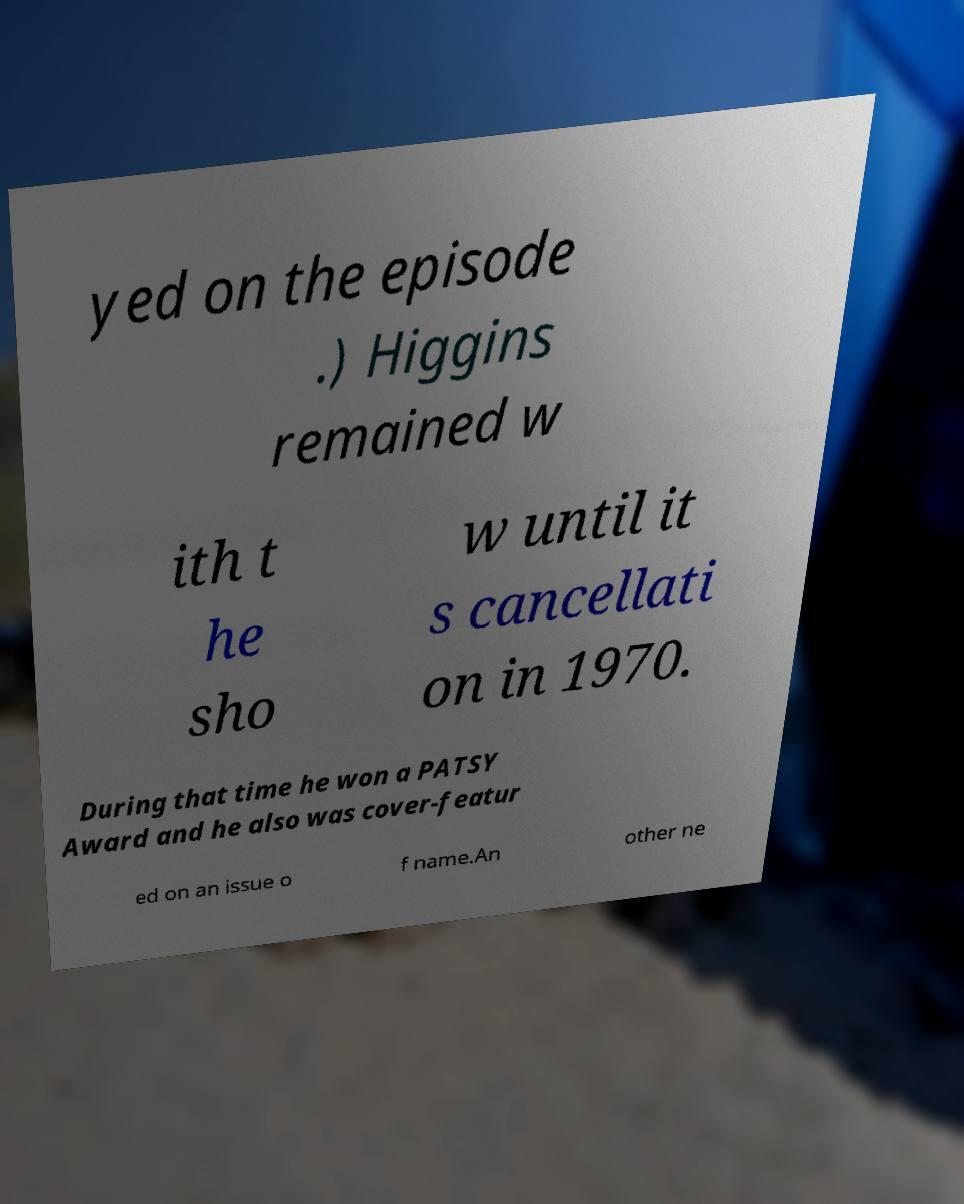I need the written content from this picture converted into text. Can you do that? yed on the episode .) Higgins remained w ith t he sho w until it s cancellati on in 1970. During that time he won a PATSY Award and he also was cover-featur ed on an issue o f name.An other ne 